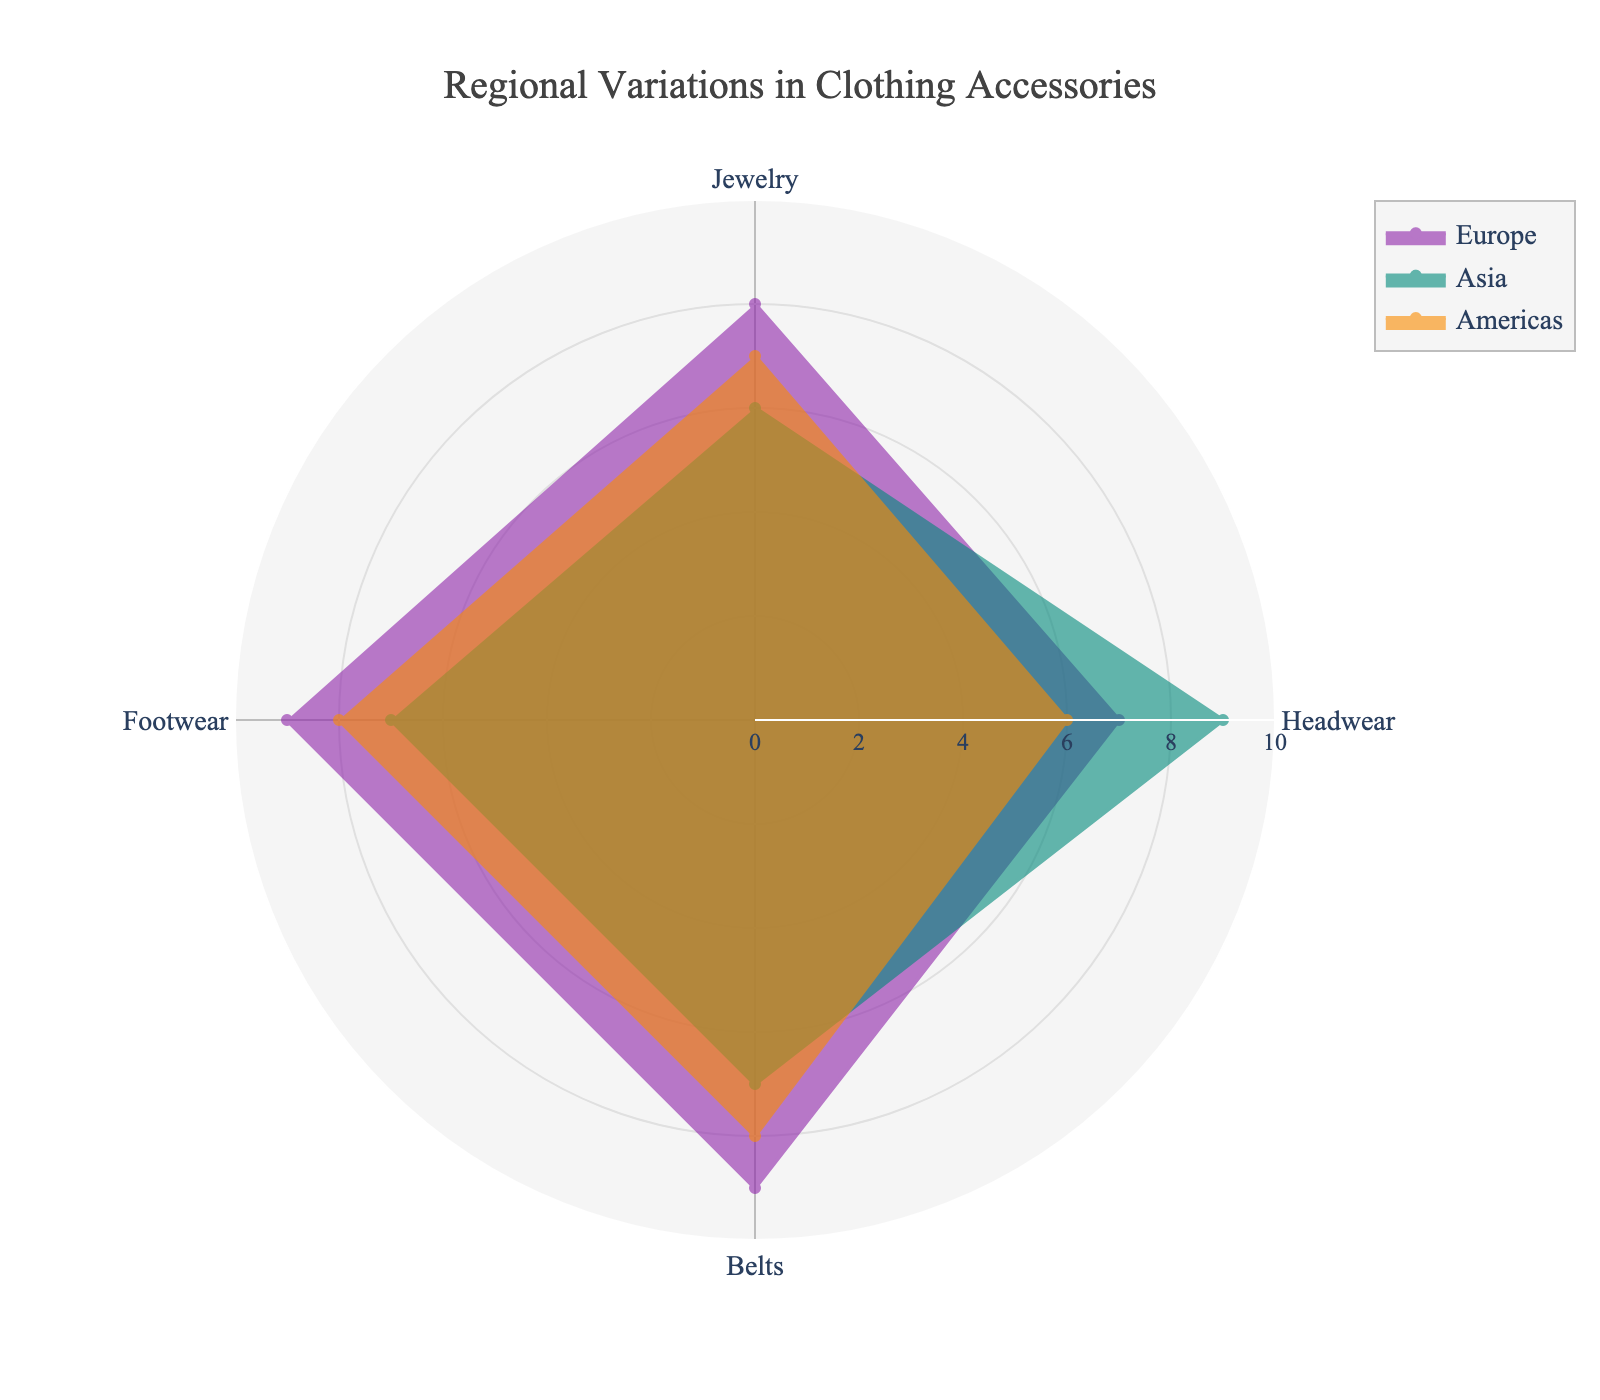What is the title of the radar chart? The title is written at the top of the chart. It states "Regional Variations in Clothing Accessories."
Answer: Regional Variations in Clothing Accessories Which region has the highest value for Jewelry? By looking at the radial axis for the Jewelry category, we see that Europe has the highest value of 8.
Answer: Europe How do the values for Headwear compare between Asia and Europe? By examining the radar chart, Asia has a value of 9 for Headwear, whereas Europe has a value of 7. Thus, Asia has a higher value for Headwear compared to Europe.
Answer: Asia (9 is greater than 7) What is the average value of all categories for the Americas region? To find the average, sum the values for Jewelry, Headwear, Belts, and Footwear in the Americas: 7 + 6 + 8 + 8 = 29. Then divide by 4 (number of categories): 29 / 4 = 7.25.
Answer: 7.25 Which category shows the least variation across all regions? To determine the least variation, observe the spread of values in each category. Headwear shows the values of 7, 9, 6, which have the greatest spread. Jewelry values are 8, 6, 7. Belts are 9, 7, 8. Footwear values are 9, 7, 8. Jewelry has the values closest to each other.
Answer: Jewelry How many regions score a 9 in at least one category? By inspecting the radar chart, Europe scores a 9 in Belts and Footwear, and Asia scores a 9 in Headwear. Thus, two regions score a 9 in at least one category.
Answer: 2 What is the difference in the Belts category between Europe and Asia? The radar chart shows that Europe has a value of 9 for Belts and Asia has a value of 7. The difference is 9 - 7 = 2.
Answer: 2 Are there any categories where all regions have the same value? By comparing the values of all regions across categories, it is evident that no category has the same value for all regions.
Answer: No Which region has the lowest combined total for the categories shown? Compute the combined total by summing up the values for each region. Europe: 8+7+9+9 = 33, Asia: 6+9+7+7 = 29, Americas: 7+6+8+8 = 29. The lowest combined total (29) is shared by Asia and the Americas.
Answer: Asia and the Americas Between which two regions is the variation in Footwear the smallest? The variation for Footwear values for Europe, Asia, and the Americas are 9, 7, and 8, respectively. The smallest difference is between Americas (8) and Asia (7). The variation between them is 8 - 7 = 1.
Answer: Asia and the Americas 